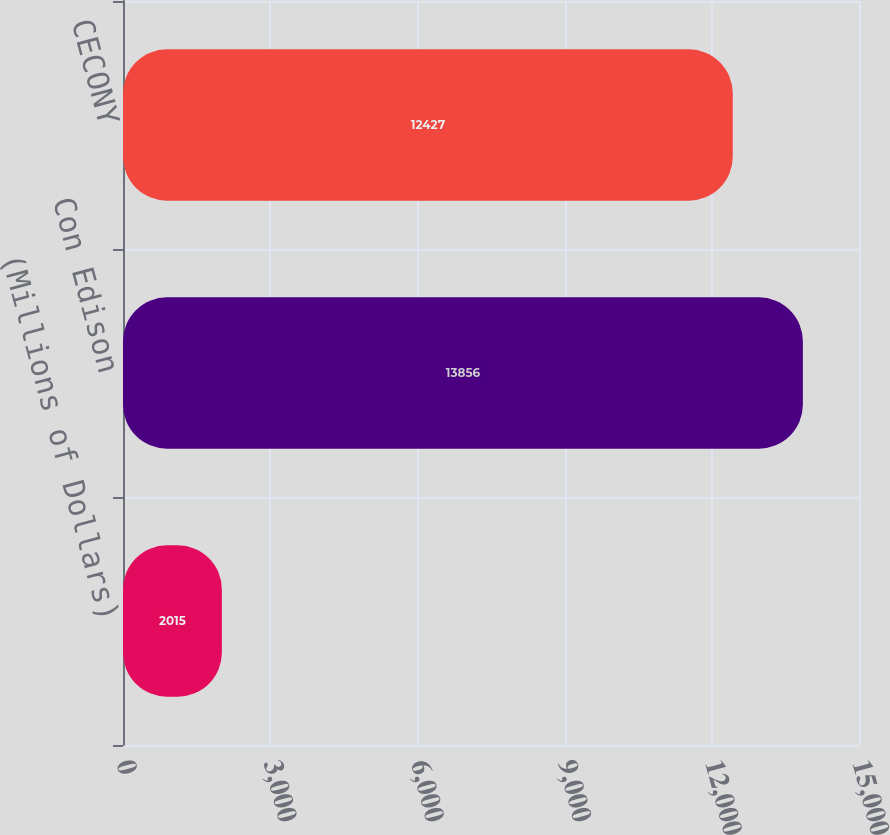<chart> <loc_0><loc_0><loc_500><loc_500><bar_chart><fcel>(Millions of Dollars)<fcel>Con Edison<fcel>CECONY<nl><fcel>2015<fcel>13856<fcel>12427<nl></chart> 